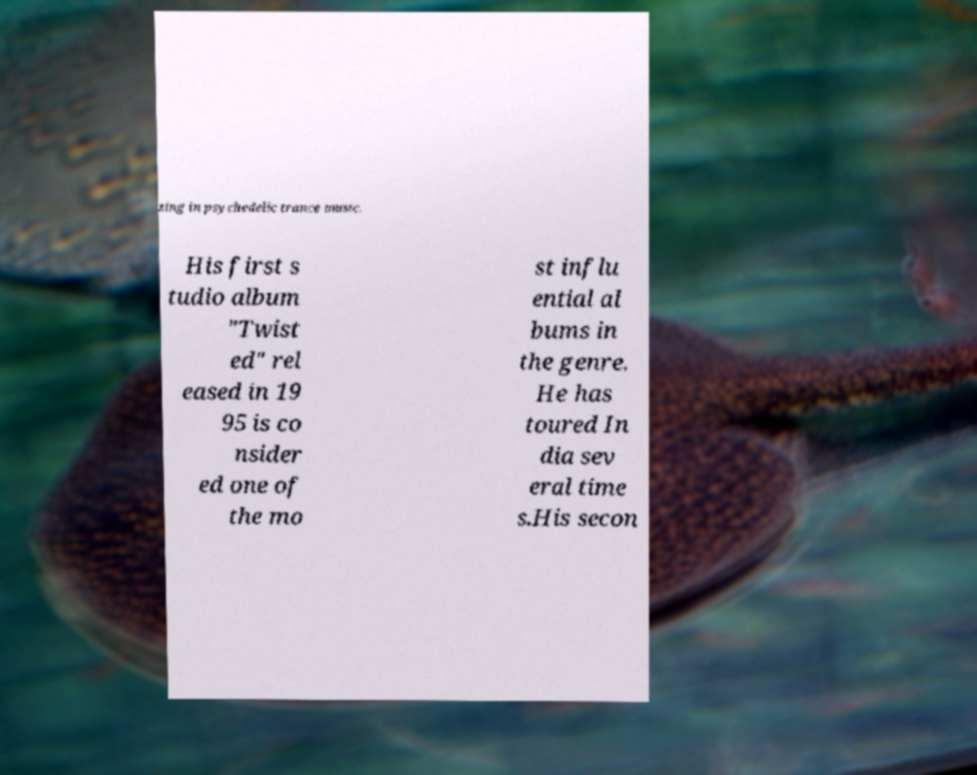Please identify and transcribe the text found in this image. zing in psychedelic trance music. His first s tudio album "Twist ed" rel eased in 19 95 is co nsider ed one of the mo st influ ential al bums in the genre. He has toured In dia sev eral time s.His secon 